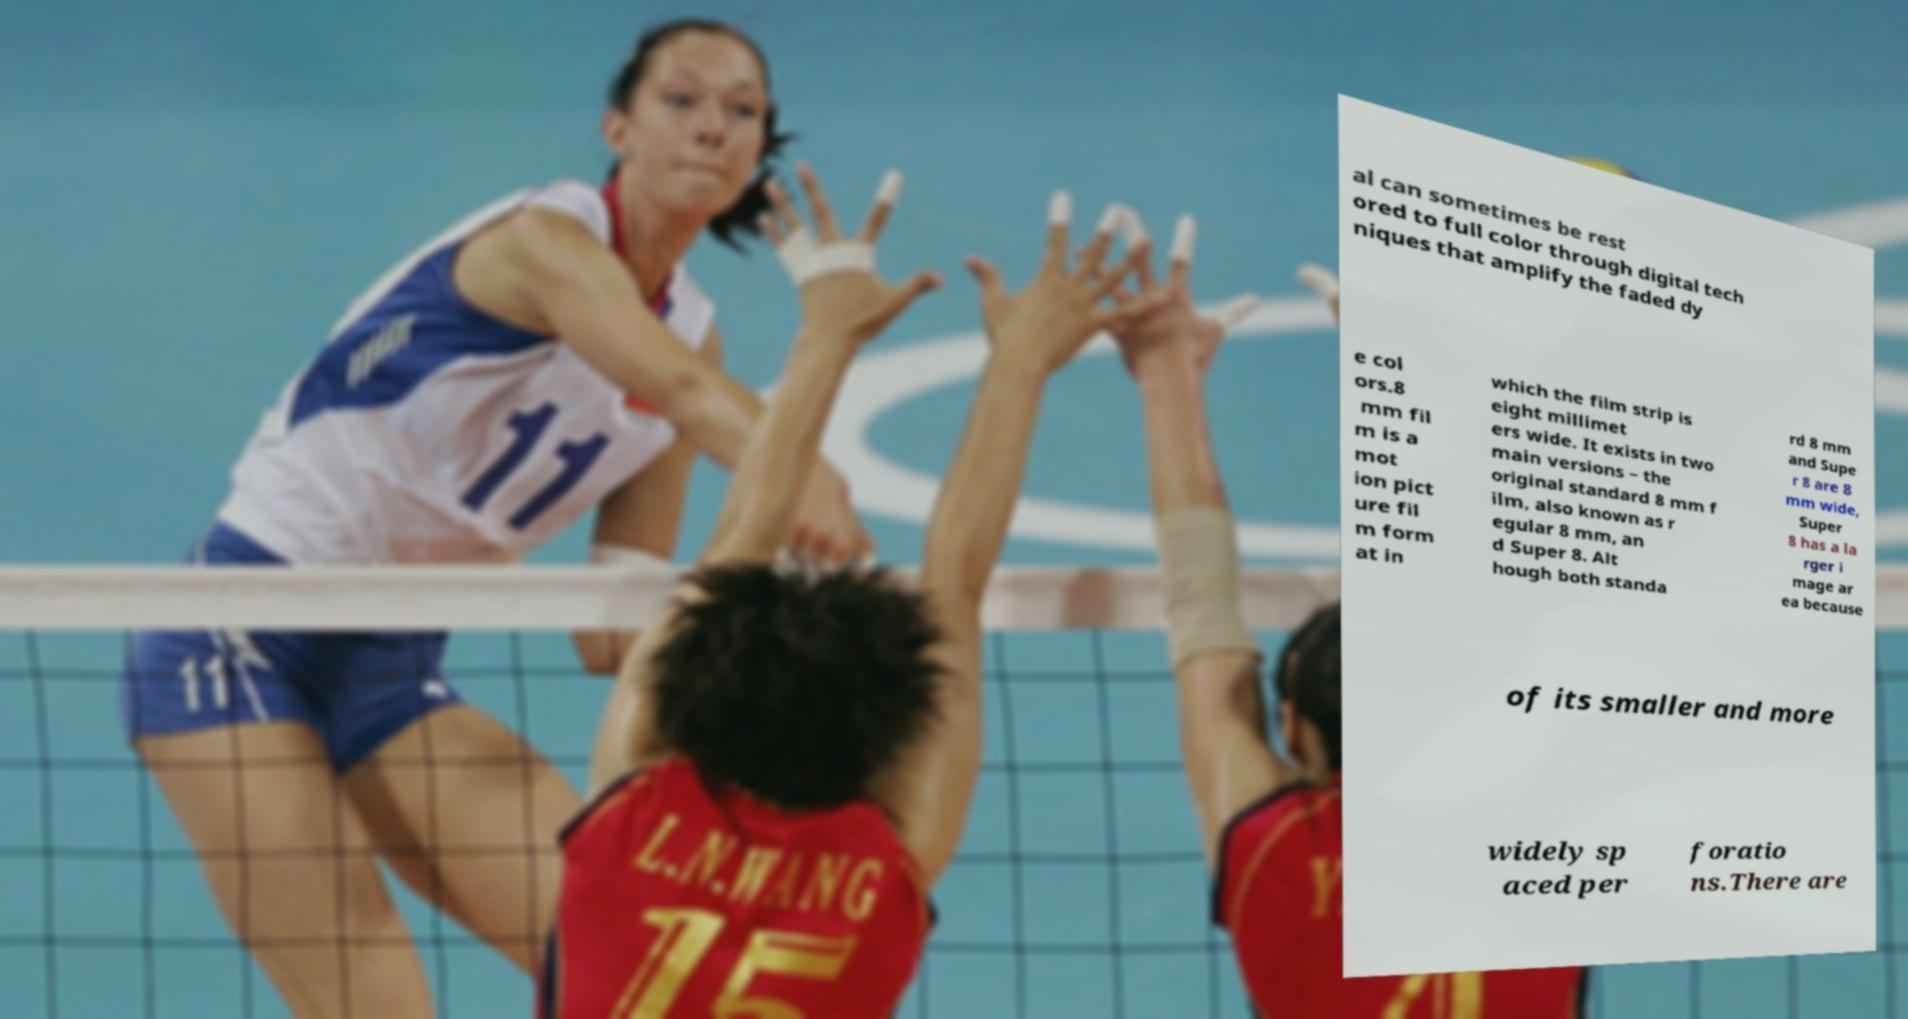For documentation purposes, I need the text within this image transcribed. Could you provide that? al can sometimes be rest ored to full color through digital tech niques that amplify the faded dy e col ors.8 mm fil m is a mot ion pict ure fil m form at in which the film strip is eight millimet ers wide. It exists in two main versions – the original standard 8 mm f ilm, also known as r egular 8 mm, an d Super 8. Alt hough both standa rd 8 mm and Supe r 8 are 8 mm wide, Super 8 has a la rger i mage ar ea because of its smaller and more widely sp aced per foratio ns.There are 